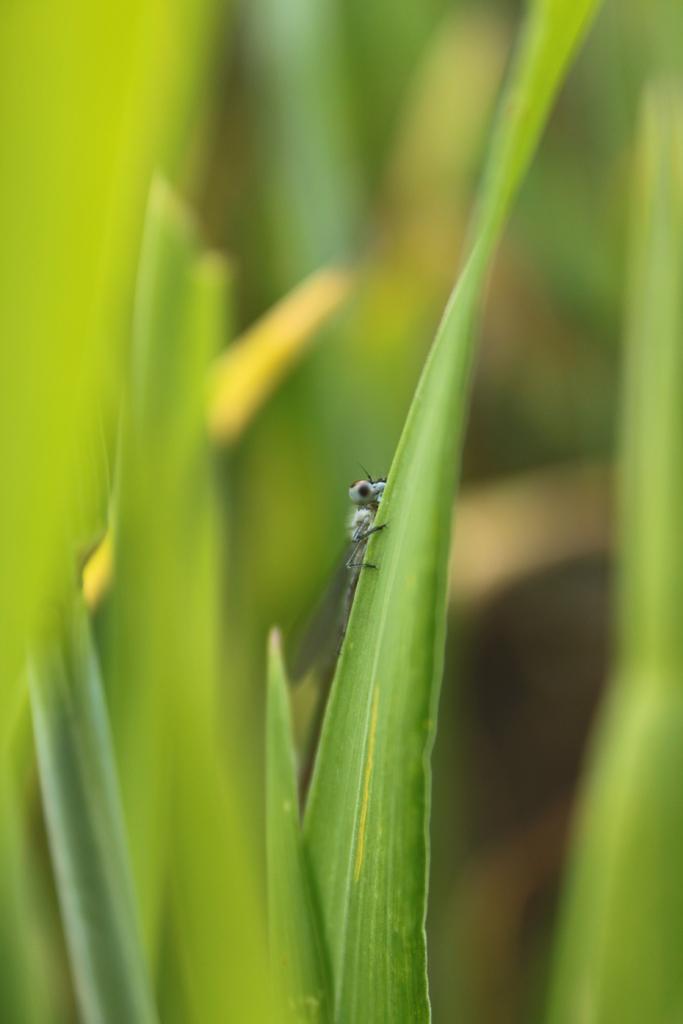Describe this image in one or two sentences. We can see insect on green leaf. In the background it is blur and green. 